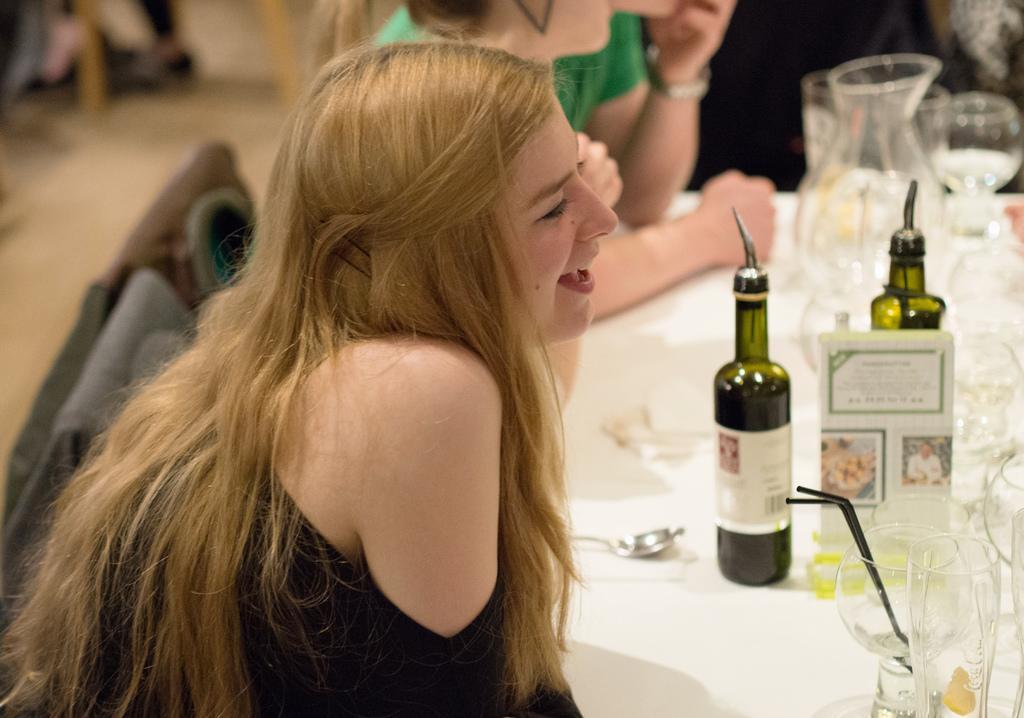How would you summarize this image in a sentence or two? This a picture consist of person sitting on the chair and there is a table ,on the table there are the bottles kept on that 